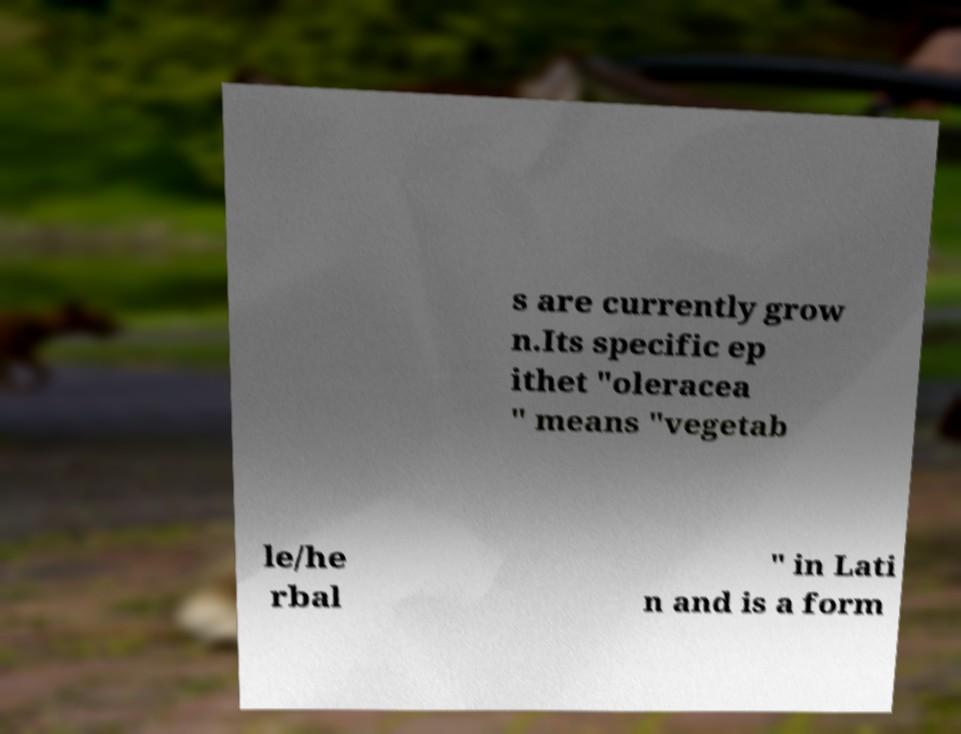Please read and relay the text visible in this image. What does it say? s are currently grow n.Its specific ep ithet "oleracea " means "vegetab le/he rbal " in Lati n and is a form 